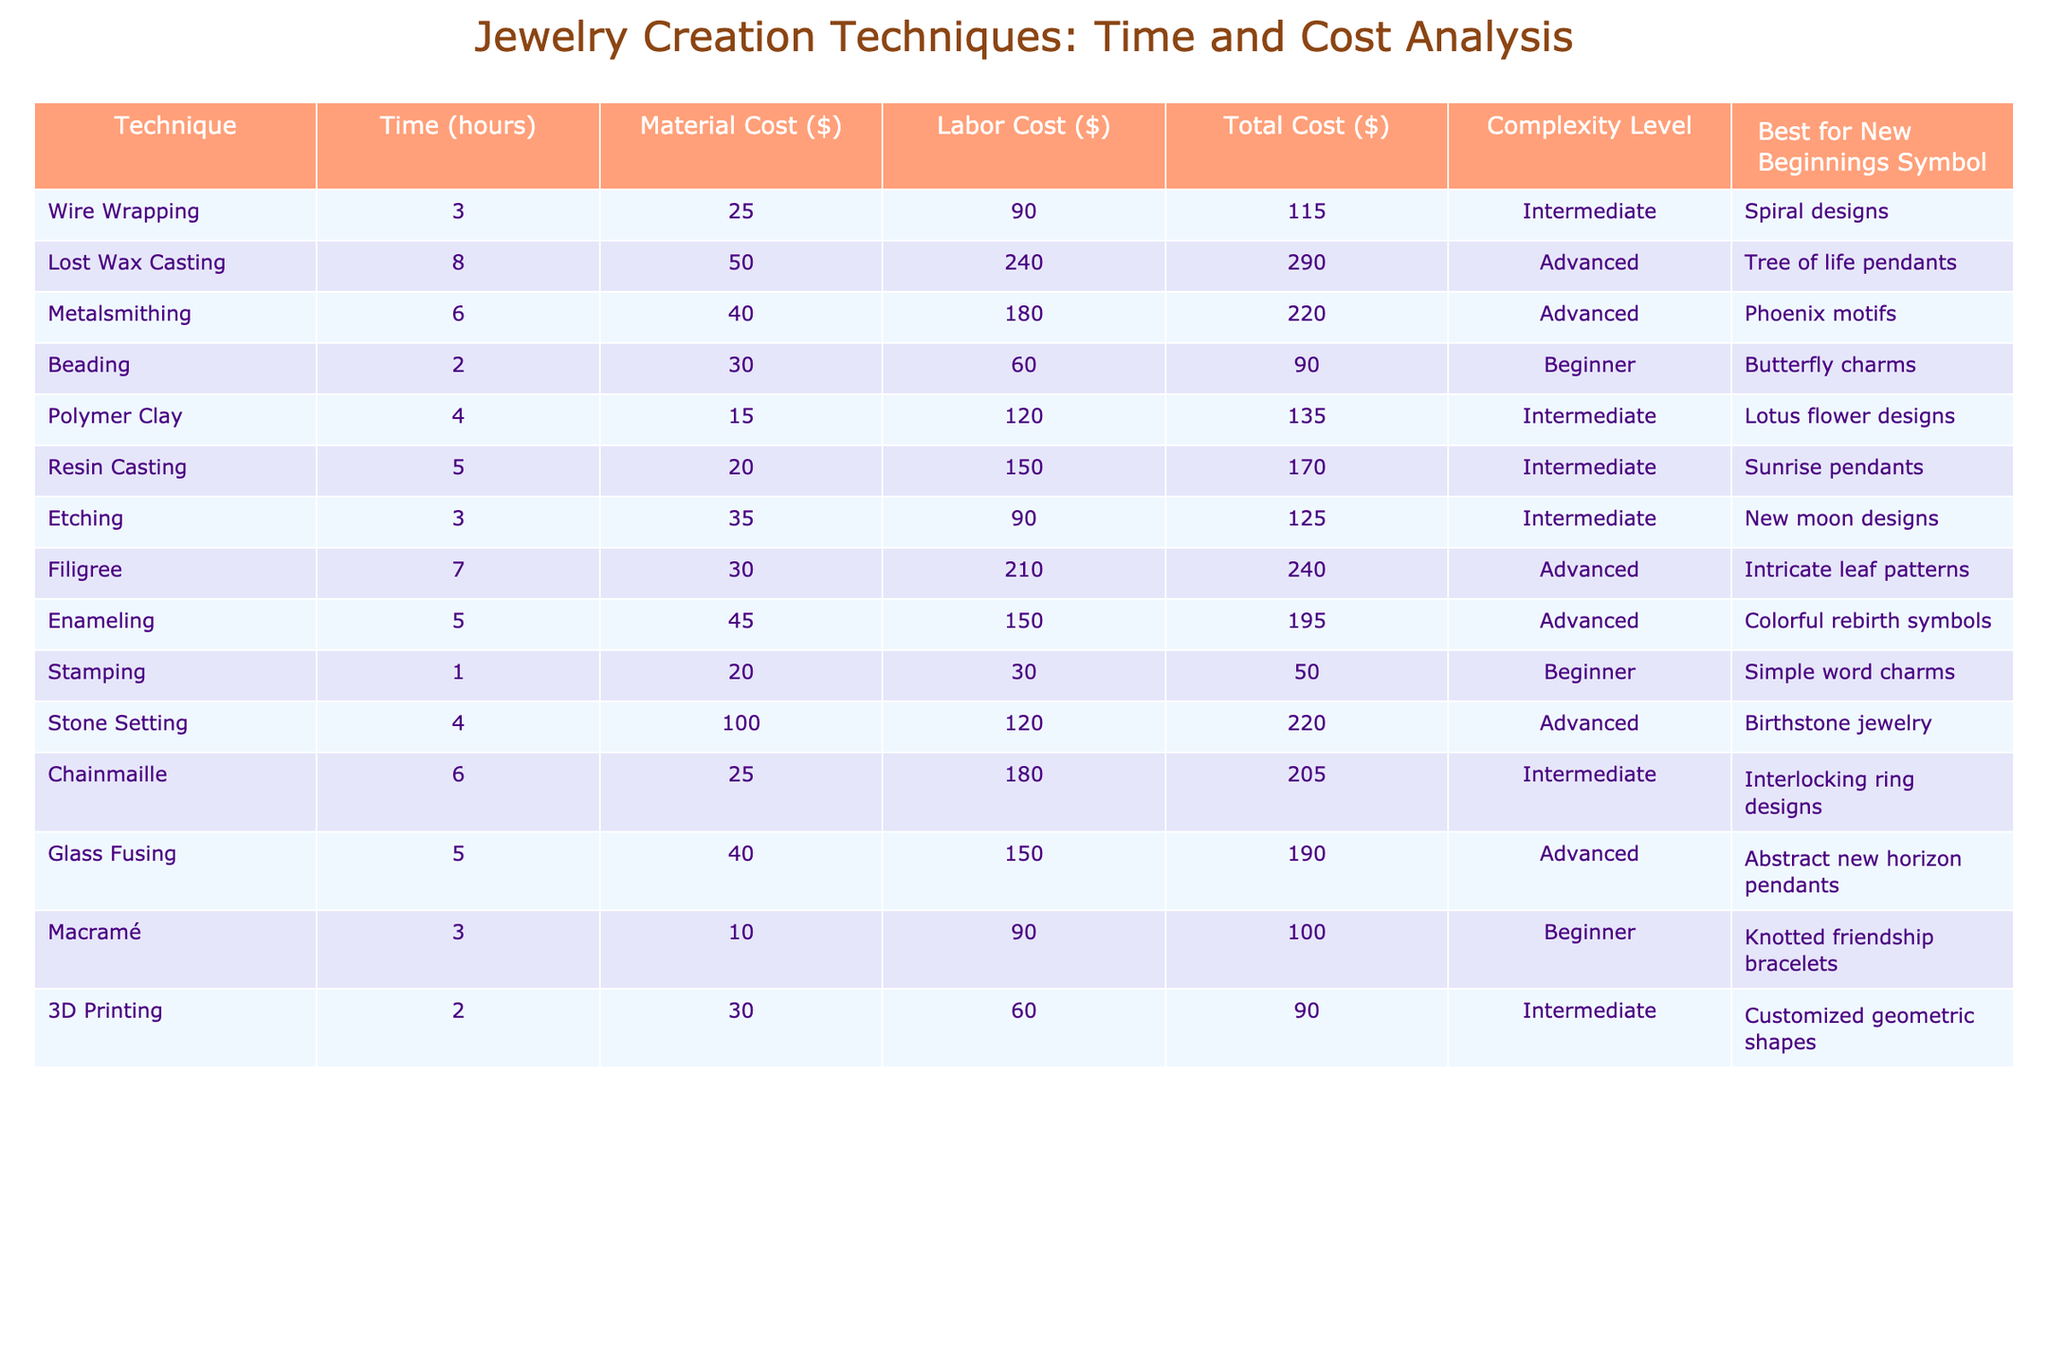What is the total cost of wire wrapping? According to the table, the total cost associated with wire wrapping is listed under the "Total Cost ($)" column, which shows a value of 115.
Answer: 115 Which technique has the highest labor cost? In the table, under the "Labor Cost ($)" column, the technique with the highest value needs to be identified. The maximum is 240 for lost wax casting.
Answer: Lost wax casting What is the average time taken across all jewelry creation techniques? To find the average time taken, sum all the values in the "Time (hours)" column, which is 3 + 8 + 6 + 2 + 4 + 5 + 3 + 7 + 5 + 1 + 4 + 6 + 5 + 3 + 2 = 60 hours. There are 15 techniques, so the average is 60/15 = 4.
Answer: 4 Is beading a beginner-level technique? The table shows that beading has a complexity level categorized as "Beginner." Therefore, the answer is yes.
Answer: Yes Which two techniques have a total cost of less than $100? By checking the "Total Cost ($)" column, we find that beading costs 90 and stamping costs 50. Both are under 100 when summed.
Answer: Beading and stamping What is the median material cost of the techniques? First, list the material costs in ascending order: 10, 15, 20, 25, 30, 40, 45, 50, 100. There are 15 material costs, so the median is the average of the 7th and 8th values, which are 30 and 50. The average is (30 + 50)/2 = 40.
Answer: 30 Which technique is best for a "Phoenix motifs" jewelry? According to the table, the technique best suited for creating a "Phoenix motifs" design falls under the description for metalsmithing.
Answer: Metalsmithing What is the total material cost for advanced-level techniques? First, identify advanced-level techniques: lost wax casting, metalsmithing, filigree, enameling, stone setting, and glass fusing. Their material costs are 50, 40, 30, 45, 100, and 40 respectively. Summing those costs gives: 50 + 40 + 30 + 45 + 100 + 40 = 305.
Answer: 305 Which technique takes the least amount of time? By analyzing the "Time (hours)" column, stamping has the lowest time of 1 hour.
Answer: Stamping Are there any techniques that cost more than $200? Checking the "Total Cost ($)" column shows several techniques costing more than 200: lost wax casting, metalsmithing, filigree, stone setting, and glass fusing. Therefore, the answer to the query is yes.
Answer: Yes 